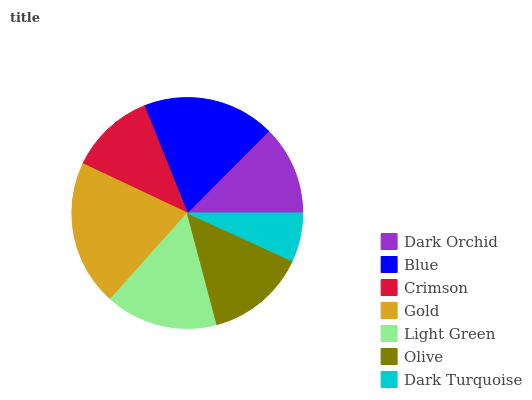Is Dark Turquoise the minimum?
Answer yes or no. Yes. Is Gold the maximum?
Answer yes or no. Yes. Is Blue the minimum?
Answer yes or no. No. Is Blue the maximum?
Answer yes or no. No. Is Blue greater than Dark Orchid?
Answer yes or no. Yes. Is Dark Orchid less than Blue?
Answer yes or no. Yes. Is Dark Orchid greater than Blue?
Answer yes or no. No. Is Blue less than Dark Orchid?
Answer yes or no. No. Is Olive the high median?
Answer yes or no. Yes. Is Olive the low median?
Answer yes or no. Yes. Is Dark Orchid the high median?
Answer yes or no. No. Is Blue the low median?
Answer yes or no. No. 